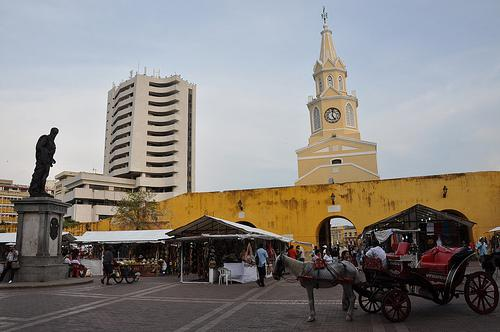Question: how many horses do you see?
Choices:
A. 2.
B. 3.
C. 4.
D. 1.
Answer with the letter. Answer: D Question: what color is the big wall in front of the buildings?
Choices:
A. Yellow.
B. White.
C. Tan.
D. Orange.
Answer with the letter. Answer: A Question: what color is the horse?
Choices:
A. Brown.
B. Black.
C. Grey.
D. White.
Answer with the letter. Answer: C Question: how many statues of men do you see in this photo?
Choices:
A. 2.
B. 1.
C. 3.
D. 4.
Answer with the letter. Answer: B Question: what color is the sky?
Choices:
A. Gray.
B. Blue.
C. Yellow.
D. White.
Answer with the letter. Answer: B 